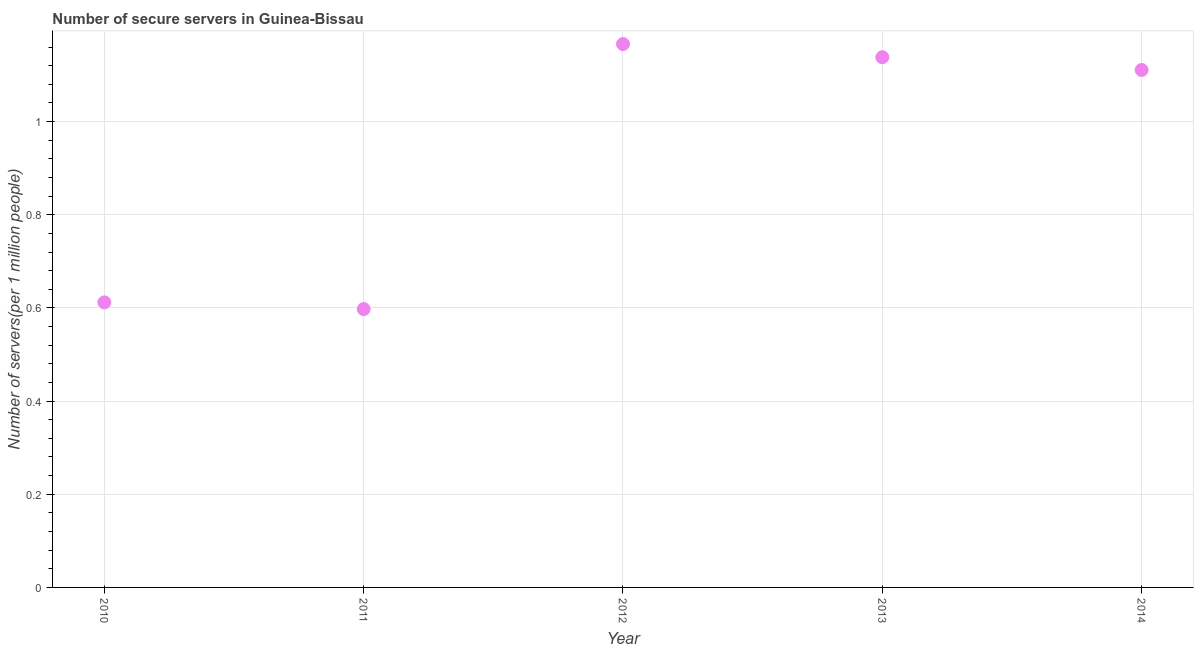What is the number of secure internet servers in 2012?
Give a very brief answer. 1.17. Across all years, what is the maximum number of secure internet servers?
Make the answer very short. 1.17. Across all years, what is the minimum number of secure internet servers?
Make the answer very short. 0.6. What is the sum of the number of secure internet servers?
Your answer should be very brief. 4.62. What is the difference between the number of secure internet servers in 2010 and 2012?
Ensure brevity in your answer.  -0.55. What is the average number of secure internet servers per year?
Your answer should be compact. 0.92. What is the median number of secure internet servers?
Provide a succinct answer. 1.11. In how many years, is the number of secure internet servers greater than 1.08 ?
Offer a very short reply. 3. Do a majority of the years between 2013 and 2014 (inclusive) have number of secure internet servers greater than 0.52 ?
Your answer should be very brief. Yes. What is the ratio of the number of secure internet servers in 2010 to that in 2011?
Your answer should be very brief. 1.02. Is the difference between the number of secure internet servers in 2010 and 2011 greater than the difference between any two years?
Provide a short and direct response. No. What is the difference between the highest and the second highest number of secure internet servers?
Ensure brevity in your answer.  0.03. Is the sum of the number of secure internet servers in 2012 and 2013 greater than the maximum number of secure internet servers across all years?
Give a very brief answer. Yes. What is the difference between the highest and the lowest number of secure internet servers?
Your answer should be compact. 0.57. Are the values on the major ticks of Y-axis written in scientific E-notation?
Give a very brief answer. No. Does the graph contain any zero values?
Provide a succinct answer. No. Does the graph contain grids?
Keep it short and to the point. Yes. What is the title of the graph?
Provide a short and direct response. Number of secure servers in Guinea-Bissau. What is the label or title of the X-axis?
Offer a terse response. Year. What is the label or title of the Y-axis?
Give a very brief answer. Number of servers(per 1 million people). What is the Number of servers(per 1 million people) in 2010?
Offer a terse response. 0.61. What is the Number of servers(per 1 million people) in 2011?
Make the answer very short. 0.6. What is the Number of servers(per 1 million people) in 2012?
Offer a terse response. 1.17. What is the Number of servers(per 1 million people) in 2013?
Your answer should be compact. 1.14. What is the Number of servers(per 1 million people) in 2014?
Offer a terse response. 1.11. What is the difference between the Number of servers(per 1 million people) in 2010 and 2011?
Ensure brevity in your answer.  0.01. What is the difference between the Number of servers(per 1 million people) in 2010 and 2012?
Provide a succinct answer. -0.55. What is the difference between the Number of servers(per 1 million people) in 2010 and 2013?
Make the answer very short. -0.53. What is the difference between the Number of servers(per 1 million people) in 2010 and 2014?
Your response must be concise. -0.5. What is the difference between the Number of servers(per 1 million people) in 2011 and 2012?
Offer a terse response. -0.57. What is the difference between the Number of servers(per 1 million people) in 2011 and 2013?
Keep it short and to the point. -0.54. What is the difference between the Number of servers(per 1 million people) in 2011 and 2014?
Your response must be concise. -0.51. What is the difference between the Number of servers(per 1 million people) in 2012 and 2013?
Make the answer very short. 0.03. What is the difference between the Number of servers(per 1 million people) in 2012 and 2014?
Your answer should be very brief. 0.06. What is the difference between the Number of servers(per 1 million people) in 2013 and 2014?
Your answer should be compact. 0.03. What is the ratio of the Number of servers(per 1 million people) in 2010 to that in 2011?
Your answer should be compact. 1.02. What is the ratio of the Number of servers(per 1 million people) in 2010 to that in 2012?
Give a very brief answer. 0.53. What is the ratio of the Number of servers(per 1 million people) in 2010 to that in 2013?
Make the answer very short. 0.54. What is the ratio of the Number of servers(per 1 million people) in 2010 to that in 2014?
Give a very brief answer. 0.55. What is the ratio of the Number of servers(per 1 million people) in 2011 to that in 2012?
Your response must be concise. 0.51. What is the ratio of the Number of servers(per 1 million people) in 2011 to that in 2013?
Your response must be concise. 0.53. What is the ratio of the Number of servers(per 1 million people) in 2011 to that in 2014?
Your answer should be compact. 0.54. What is the ratio of the Number of servers(per 1 million people) in 2012 to that in 2014?
Provide a succinct answer. 1.05. What is the ratio of the Number of servers(per 1 million people) in 2013 to that in 2014?
Ensure brevity in your answer.  1.02. 